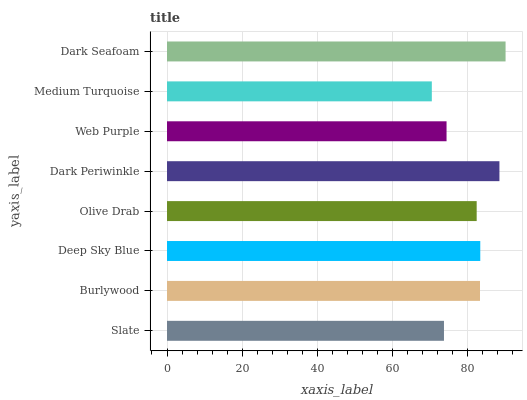Is Medium Turquoise the minimum?
Answer yes or no. Yes. Is Dark Seafoam the maximum?
Answer yes or no. Yes. Is Burlywood the minimum?
Answer yes or no. No. Is Burlywood the maximum?
Answer yes or no. No. Is Burlywood greater than Slate?
Answer yes or no. Yes. Is Slate less than Burlywood?
Answer yes or no. Yes. Is Slate greater than Burlywood?
Answer yes or no. No. Is Burlywood less than Slate?
Answer yes or no. No. Is Burlywood the high median?
Answer yes or no. Yes. Is Olive Drab the low median?
Answer yes or no. Yes. Is Medium Turquoise the high median?
Answer yes or no. No. Is Dark Periwinkle the low median?
Answer yes or no. No. 